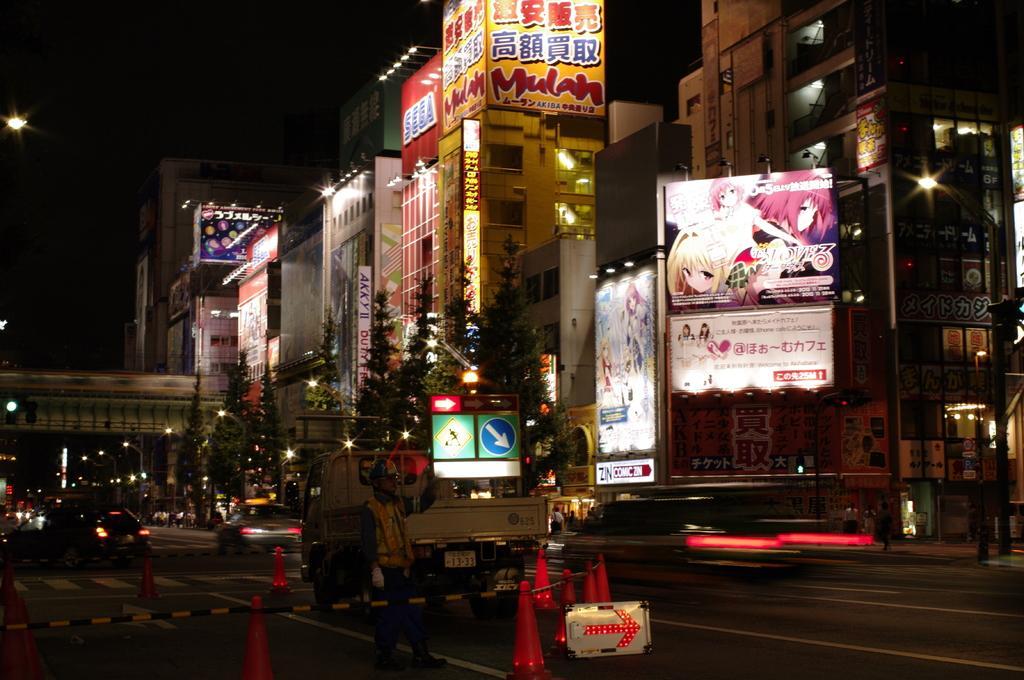In one or two sentences, can you explain what this image depicts? In this image we can see many buildings. There are many trees a side of road. There is a street light, at the right most of the image. There are few vehicles moving on the road. A person is walking on the road. There are some hoardings attached to the buildings. 